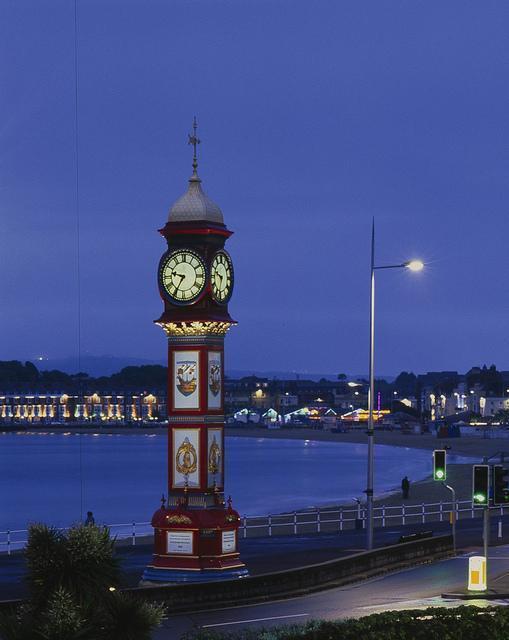What should traffic do by the light?
Make your selection and explain in format: 'Answer: answer
Rationale: rationale.'
Options: Move backwards, go, stop, yield. Answer: go.
Rationale: The traffic light is green. a green light is a signal that traffic may proceed. 